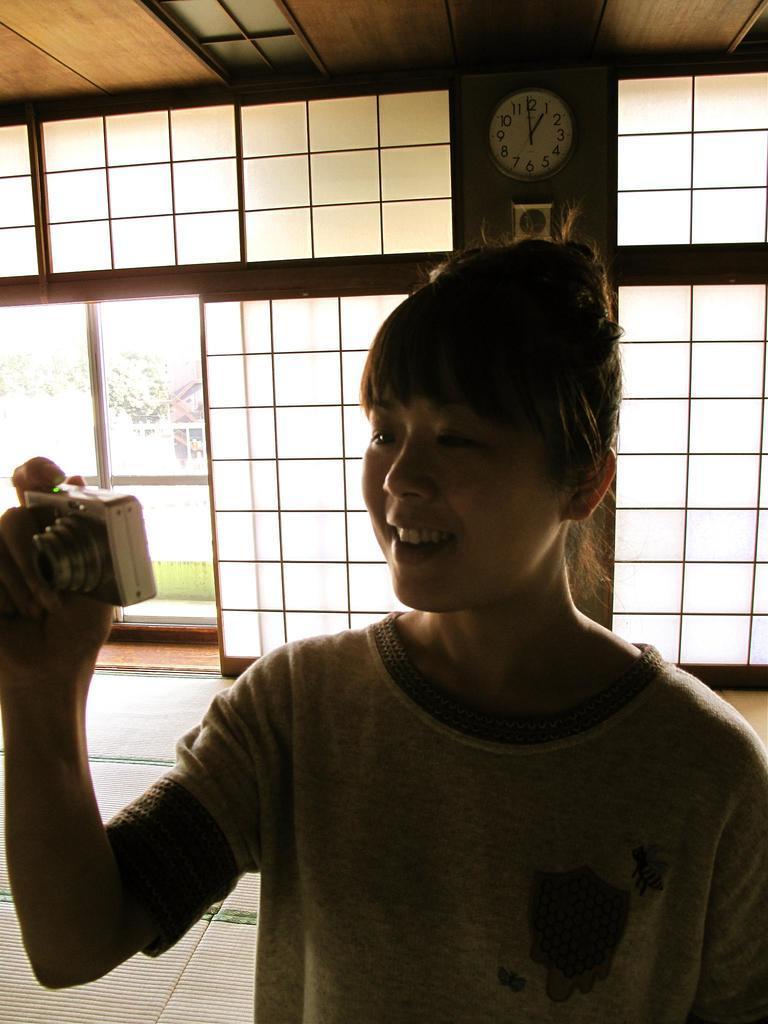Please provide a concise description of this image. In this image we can see a woman holding a camera. At the background there is a watch. 